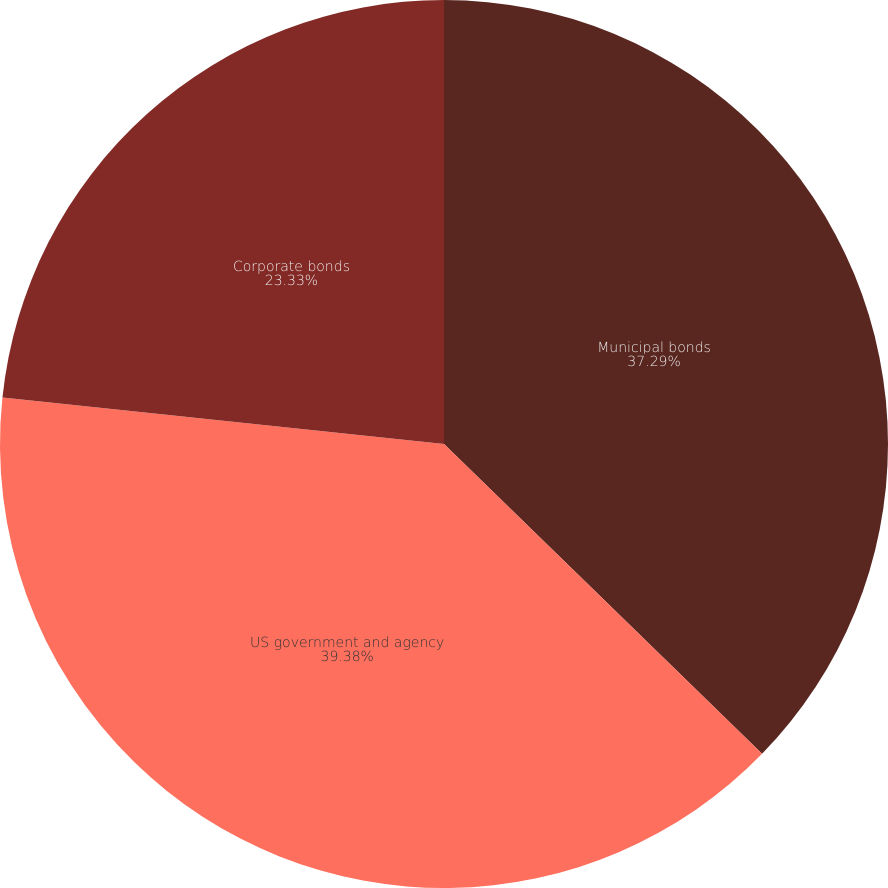Convert chart to OTSL. <chart><loc_0><loc_0><loc_500><loc_500><pie_chart><fcel>Municipal bonds<fcel>US government and agency<fcel>Corporate bonds<nl><fcel>37.29%<fcel>39.38%<fcel>23.33%<nl></chart> 